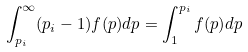<formula> <loc_0><loc_0><loc_500><loc_500>\int _ { p _ { i } } ^ { \infty } ( p _ { i } - 1 ) f ( p ) d p = \int _ { 1 } ^ { p _ { i } } f ( p ) d p</formula> 